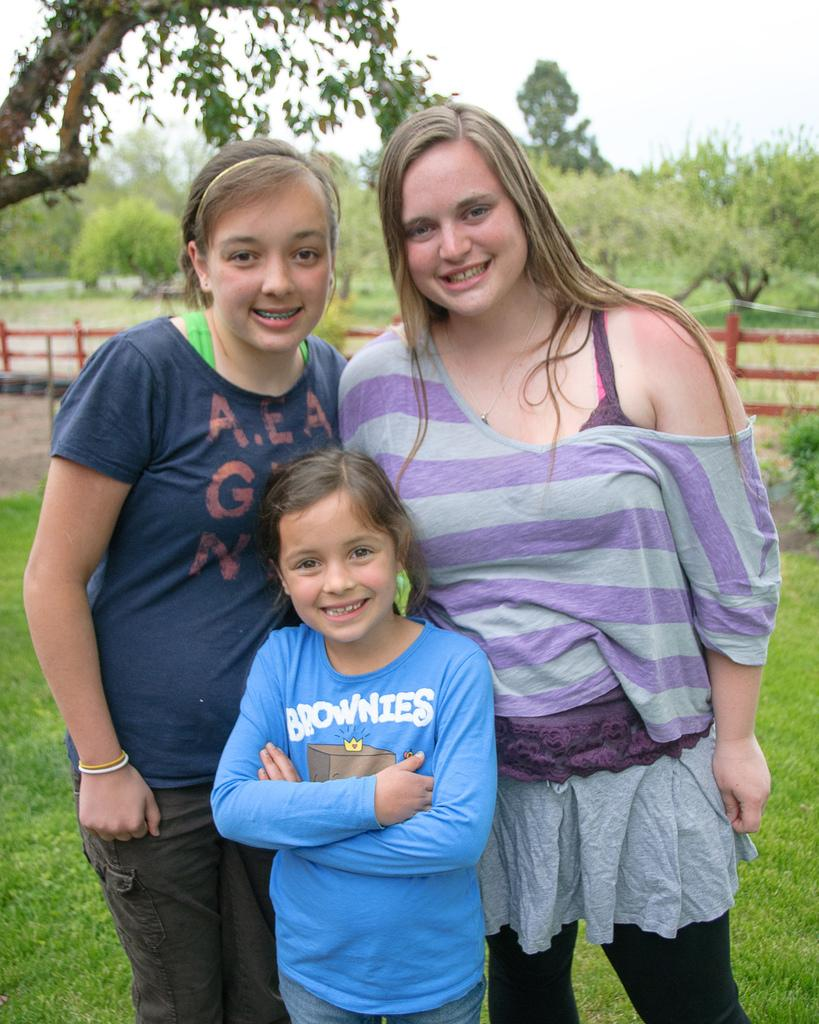How many children are in the image? There are two kids and a girl in the image. What is the facial expression of the kids and the girl? The kids and the girl are smiling. What type of surface is visible in the image? There is grass visible in the image. What is the material of the fence in the image? The fence in the image is made of wood. What can be seen on the other side of the fence? Trees are present on the other side of the fence. What type of machine is being used by the girl in the image? There is no machine present in the image; the girl is simply smiling. Does the girl have a brother in the image? The provided facts do not mention a brother, so we cannot determine if the girl has a brother in the image. 